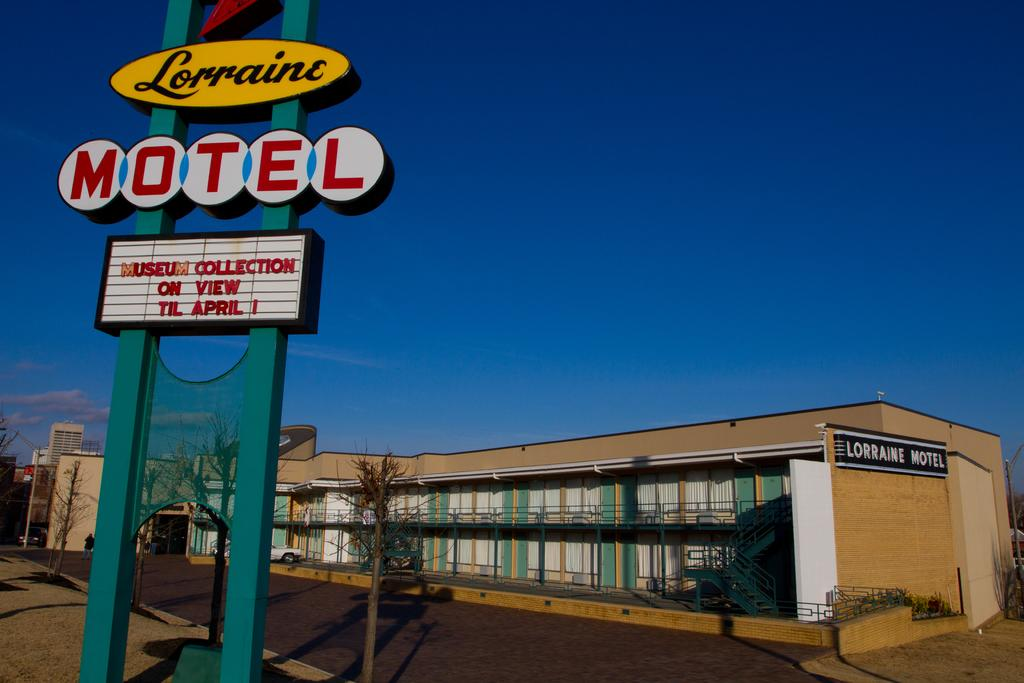What type of structures can be seen in the image? There are buildings in the image. What else can be seen on the ground in the image? There are vehicles on the road in the image. What type of animals are visible in the image? There are birds visible in the image. What type of vegetation is present in the image? There are trees in the image. What is visible in the background of the image? The sky is visible in the background of the image. What book is your aunt reading in the image? There is no aunt or book present in the image. What song is being sung by the birds in the image? Birds do not sing songs, and there is no indication of any song being sung in the image. 